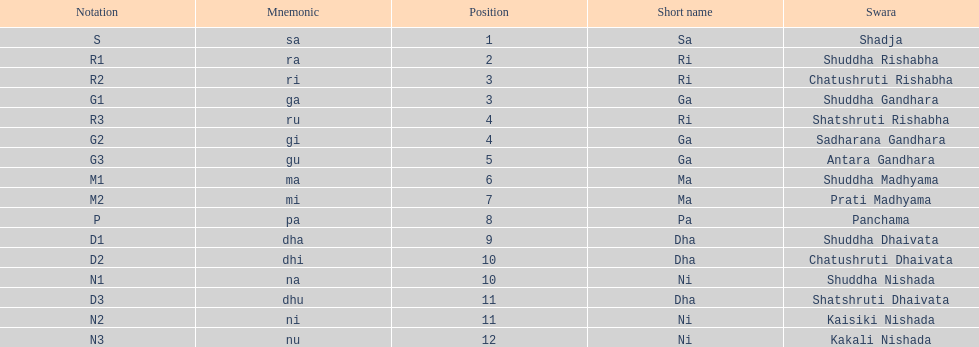Could you help me parse every detail presented in this table? {'header': ['Notation', 'Mnemonic', 'Position', 'Short name', 'Swara'], 'rows': [['S', 'sa', '1', 'Sa', 'Shadja'], ['R1', 'ra', '2', 'Ri', 'Shuddha Rishabha'], ['R2', 'ri', '3', 'Ri', 'Chatushruti Rishabha'], ['G1', 'ga', '3', 'Ga', 'Shuddha Gandhara'], ['R3', 'ru', '4', 'Ri', 'Shatshruti Rishabha'], ['G2', 'gi', '4', 'Ga', 'Sadharana Gandhara'], ['G3', 'gu', '5', 'Ga', 'Antara Gandhara'], ['M1', 'ma', '6', 'Ma', 'Shuddha Madhyama'], ['M2', 'mi', '7', 'Ma', 'Prati Madhyama'], ['P', 'pa', '8', 'Pa', 'Panchama'], ['D1', 'dha', '9', 'Dha', 'Shuddha Dhaivata'], ['D2', 'dhi', '10', 'Dha', 'Chatushruti Dhaivata'], ['N1', 'na', '10', 'Ni', 'Shuddha Nishada'], ['D3', 'dhu', '11', 'Dha', 'Shatshruti Dhaivata'], ['N2', 'ni', '11', 'Ni', 'Kaisiki Nishada'], ['N3', 'nu', '12', 'Ni', 'Kakali Nishada']]} How many swaras do not have dhaivata in their name? 13. 